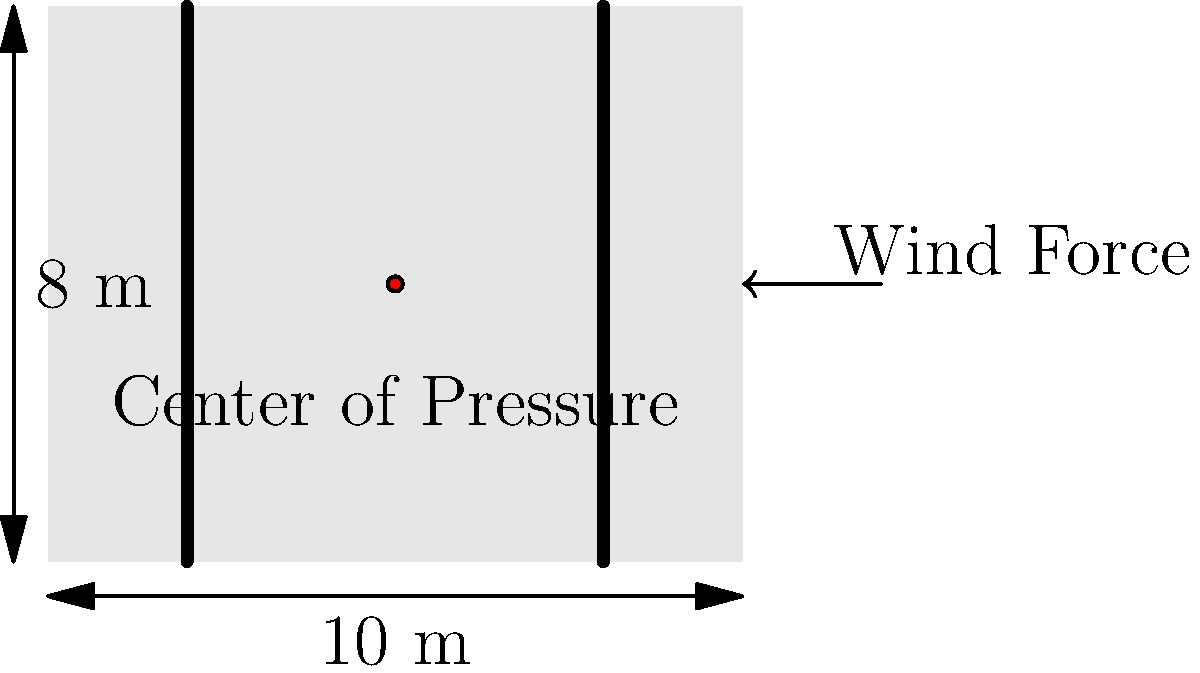A groovy retro-style billboard featuring forgotten pop stars from the 80s is being designed for a busy intersection. The billboard measures 10 m wide and 8 m high, with its center of pressure located at the geometric center. If the wind pressure acting on the billboard is 2 kN/m², what is the total wind force acting on the structure? Additionally, calculate the overturning moment at the base of the billboard. Let's break this down step-by-step, keeping in mind our love for those one-hit wonders!

1. Calculate the area of the billboard:
   Area = Width × Height
   Area = 10 m × 8 m = 80 m²

2. Calculate the total wind force:
   Wind Force = Wind Pressure × Area
   Wind Force = 2 kN/m² × 80 m² = 160 kN

3. Determine the location of the center of pressure:
   The center of pressure is at the geometric center, which is:
   Horizontal distance from edge = 10 m ÷ 2 = 5 m
   Vertical distance from base = 8 m ÷ 2 = 4 m

4. Calculate the overturning moment:
   Overturning Moment = Wind Force × Vertical distance to center of pressure
   Overturning Moment = 160 kN × 4 m = 640 kN·m

Just like how Toni Basil's "Mickey" turned the music world upside down, this wind force is trying to overturn our billboard!
Answer: Wind Force: 160 kN; Overturning Moment: 640 kN·m 